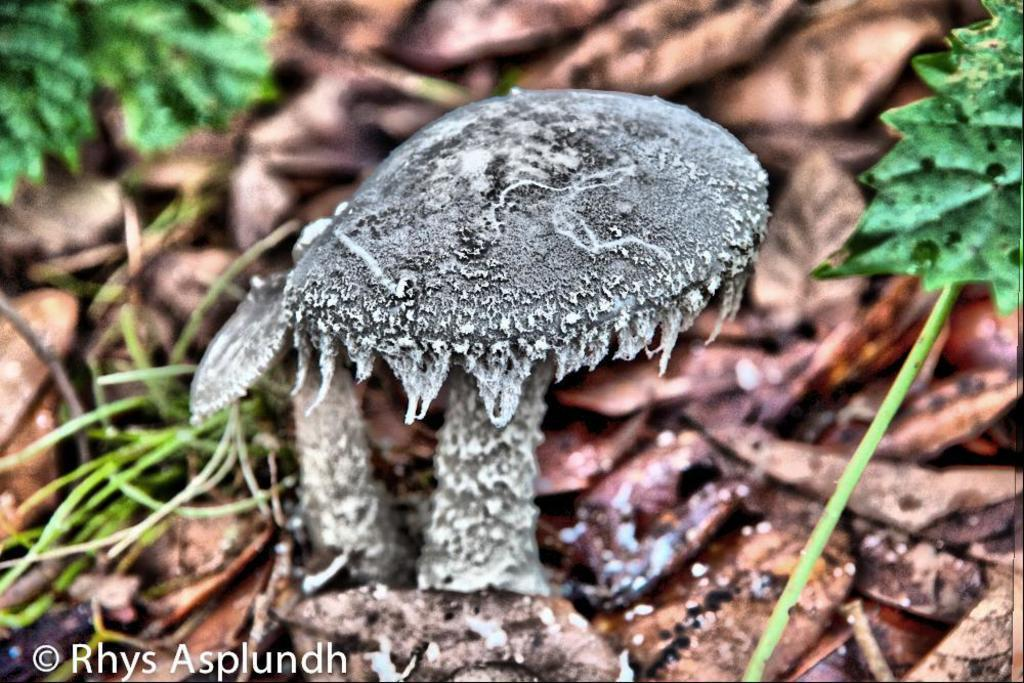What type of fungi can be seen in the image? There are mushrooms in the image. What type of plant material is present in the image? Dried leaves and green leaves are visible in the image. Where is the text located in the image? The text is in the bottom left corner of the image. What type of bean is growing on the gate in the image? There is no gate or bean present in the image. 